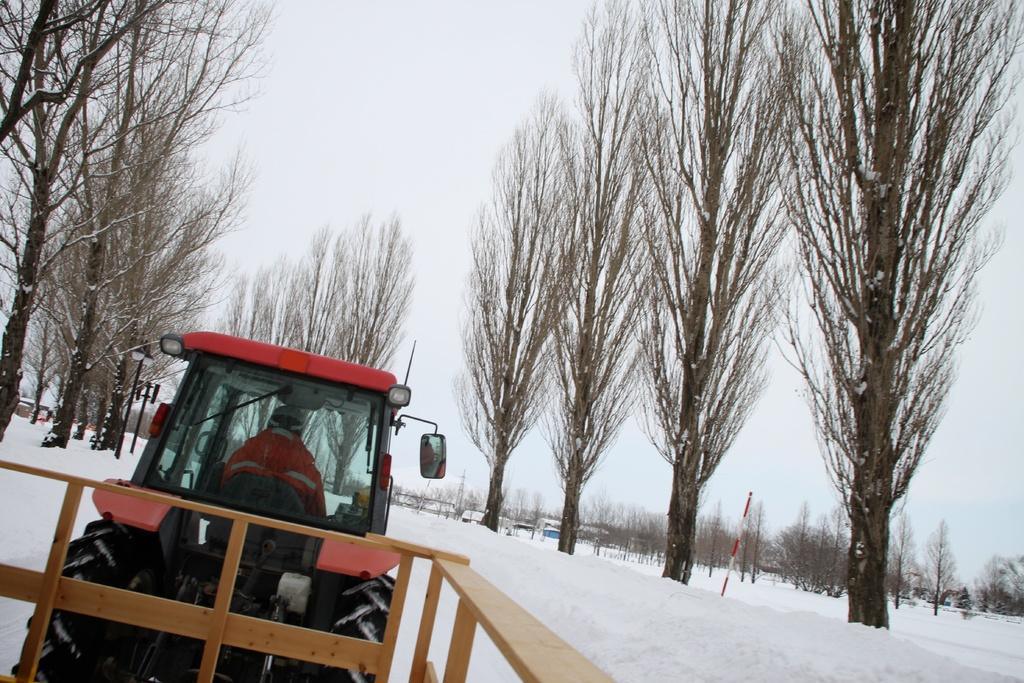Can you describe this image briefly? In this picture we can see a person sitting in a vehicle, wooden fence, snow, poles, trees and in the background we can see the sky. 